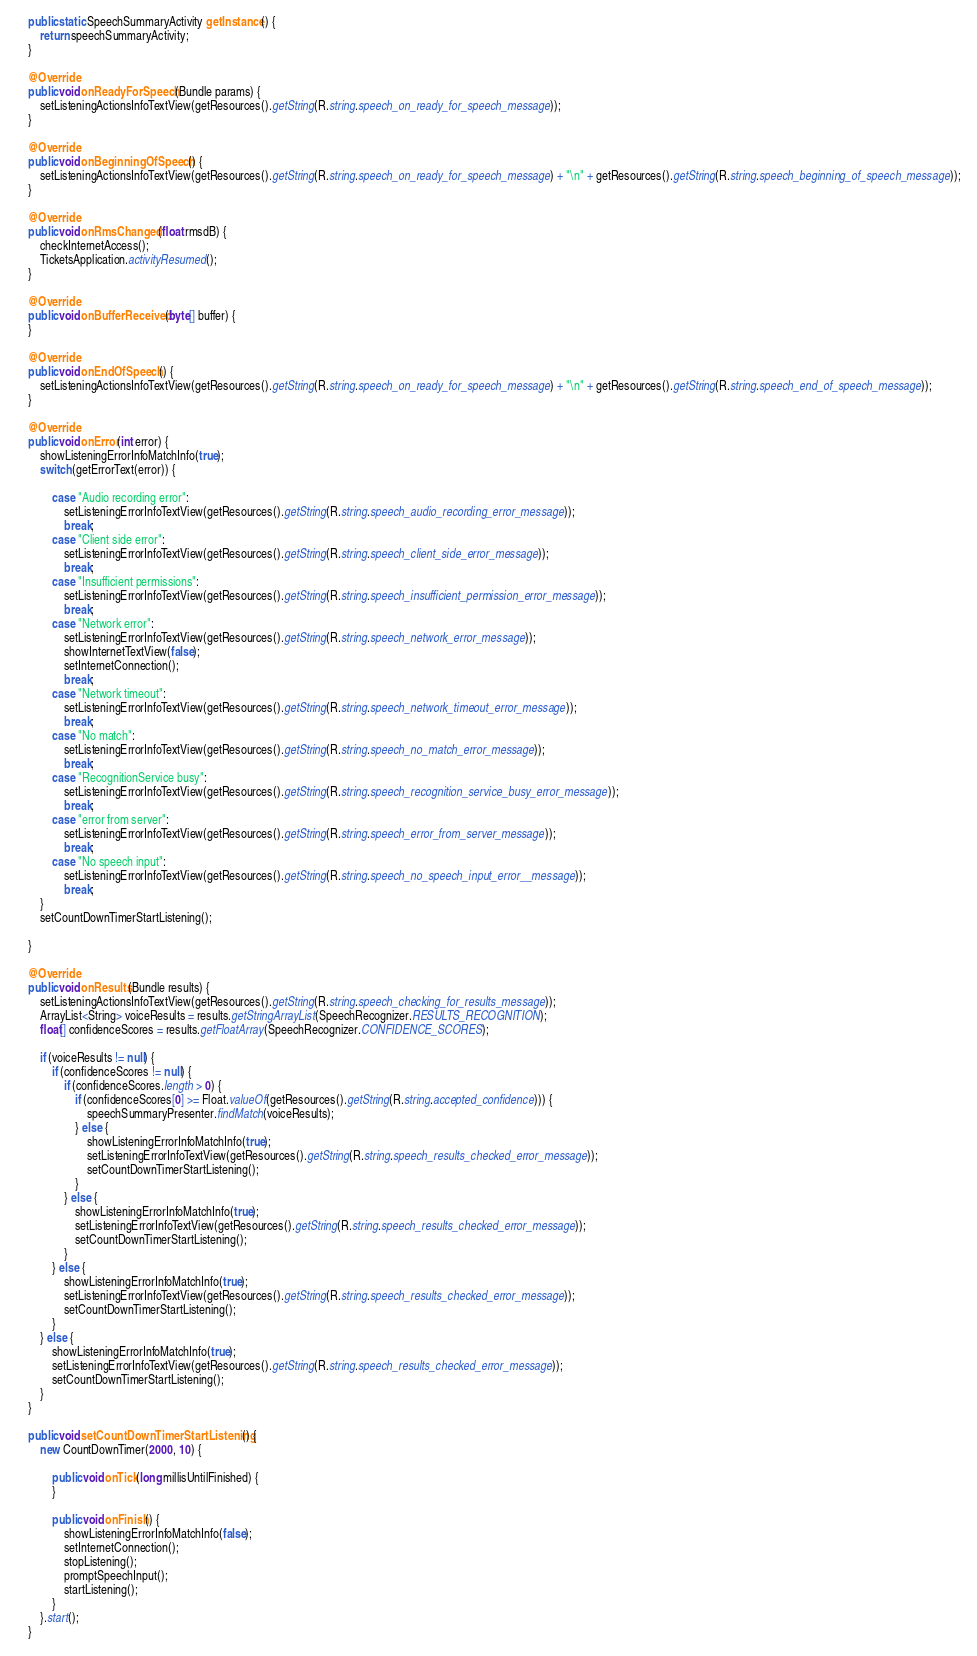Convert code to text. <code><loc_0><loc_0><loc_500><loc_500><_Java_>
    public static SpeechSummaryActivity getInstance() {
        return speechSummaryActivity;
    }

    @Override
    public void onReadyForSpeech(Bundle params) {
        setListeningActionsInfoTextView(getResources().getString(R.string.speech_on_ready_for_speech_message));
    }

    @Override
    public void onBeginningOfSpeech() {
        setListeningActionsInfoTextView(getResources().getString(R.string.speech_on_ready_for_speech_message) + "\n" + getResources().getString(R.string.speech_beginning_of_speech_message));
    }

    @Override
    public void onRmsChanged(float rmsdB) {
        checkInternetAccess();
        TicketsApplication.activityResumed();
    }

    @Override
    public void onBufferReceived(byte[] buffer) {
    }

    @Override
    public void onEndOfSpeech() {
        setListeningActionsInfoTextView(getResources().getString(R.string.speech_on_ready_for_speech_message) + "\n" + getResources().getString(R.string.speech_end_of_speech_message));
    }

    @Override
    public void onError(int error) {
        showListeningErrorInfoMatchInfo(true);
        switch (getErrorText(error)) {

            case "Audio recording error":
                setListeningErrorInfoTextView(getResources().getString(R.string.speech_audio_recording_error_message));
                break;
            case "Client side error":
                setListeningErrorInfoTextView(getResources().getString(R.string.speech_client_side_error_message));
                break;
            case "Insufficient permissions":
                setListeningErrorInfoTextView(getResources().getString(R.string.speech_insufficient_permission_error_message));
                break;
            case "Network error":
                setListeningErrorInfoTextView(getResources().getString(R.string.speech_network_error_message));
                showInternetTextView(false);
                setInternetConnection();
                break;
            case "Network timeout":
                setListeningErrorInfoTextView(getResources().getString(R.string.speech_network_timeout_error_message));
                break;
            case "No match":
                setListeningErrorInfoTextView(getResources().getString(R.string.speech_no_match_error_message));
                break;
            case "RecognitionService busy":
                setListeningErrorInfoTextView(getResources().getString(R.string.speech_recognition_service_busy_error_message));
                break;
            case "error from server":
                setListeningErrorInfoTextView(getResources().getString(R.string.speech_error_from_server_message));
                break;
            case "No speech input":
                setListeningErrorInfoTextView(getResources().getString(R.string.speech_no_speech_input_error__message));
                break;
        }
        setCountDownTimerStartListening();

    }

    @Override
    public void onResults(Bundle results) {
        setListeningActionsInfoTextView(getResources().getString(R.string.speech_checking_for_results_message));
        ArrayList<String> voiceResults = results.getStringArrayList(SpeechRecognizer.RESULTS_RECOGNITION);
        float[] confidenceScores = results.getFloatArray(SpeechRecognizer.CONFIDENCE_SCORES);

        if (voiceResults != null) {
            if (confidenceScores != null) {
                if (confidenceScores.length > 0) {
                    if (confidenceScores[0] >= Float.valueOf(getResources().getString(R.string.accepted_confidence))) {
                        speechSummaryPresenter.findMatch(voiceResults);
                    } else {
                        showListeningErrorInfoMatchInfo(true);
                        setListeningErrorInfoTextView(getResources().getString(R.string.speech_results_checked_error_message));
                        setCountDownTimerStartListening();
                    }
                } else {
                    showListeningErrorInfoMatchInfo(true);
                    setListeningErrorInfoTextView(getResources().getString(R.string.speech_results_checked_error_message));
                    setCountDownTimerStartListening();
                }
            } else {
                showListeningErrorInfoMatchInfo(true);
                setListeningErrorInfoTextView(getResources().getString(R.string.speech_results_checked_error_message));
                setCountDownTimerStartListening();
            }
        } else {
            showListeningErrorInfoMatchInfo(true);
            setListeningErrorInfoTextView(getResources().getString(R.string.speech_results_checked_error_message));
            setCountDownTimerStartListening();
        }
    }

    public void setCountDownTimerStartListening() {
        new CountDownTimer(2000, 10) {

            public void onTick(long millisUntilFinished) {
            }

            public void onFinish() {
                showListeningErrorInfoMatchInfo(false);
                setInternetConnection();
                stopListening();
                promptSpeechInput();
                startListening();
            }
        }.start();
    }
</code> 